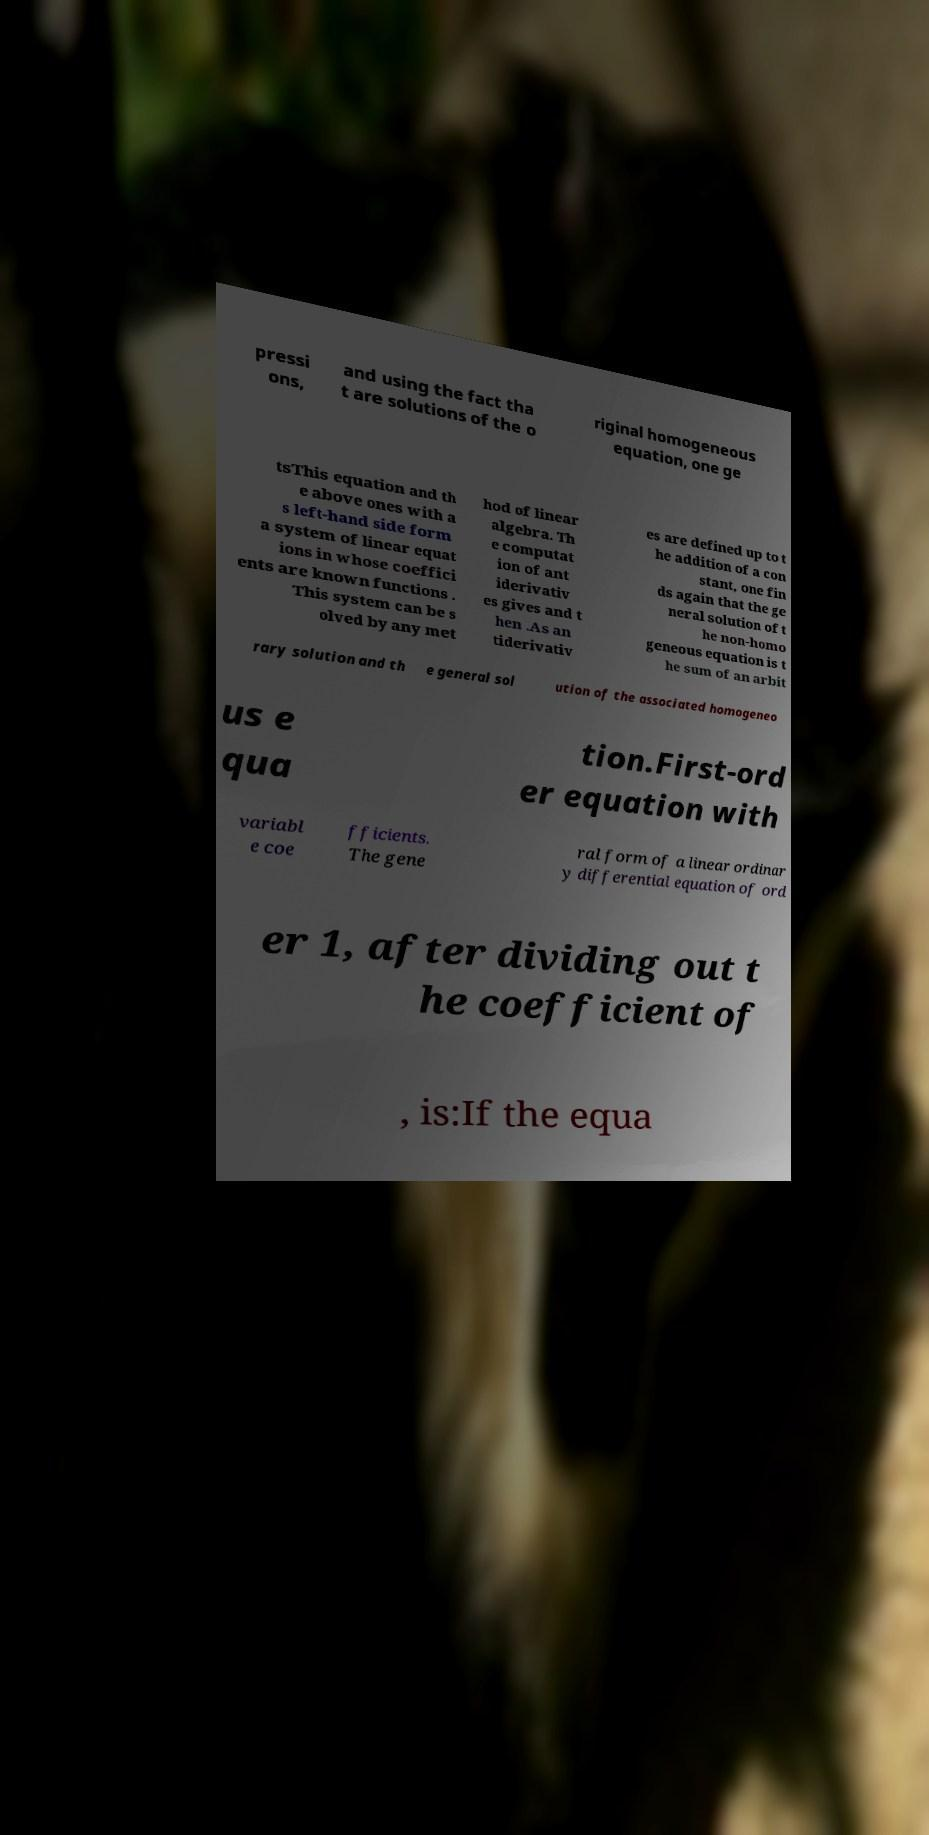For documentation purposes, I need the text within this image transcribed. Could you provide that? pressi ons, and using the fact tha t are solutions of the o riginal homogeneous equation, one ge tsThis equation and th e above ones with a s left-hand side form a system of linear equat ions in whose coeffici ents are known functions . This system can be s olved by any met hod of linear algebra. Th e computat ion of ant iderivativ es gives and t hen .As an tiderivativ es are defined up to t he addition of a con stant, one fin ds again that the ge neral solution of t he non-homo geneous equation is t he sum of an arbit rary solution and th e general sol ution of the associated homogeneo us e qua tion.First-ord er equation with variabl e coe fficients. The gene ral form of a linear ordinar y differential equation of ord er 1, after dividing out t he coefficient of , is:If the equa 